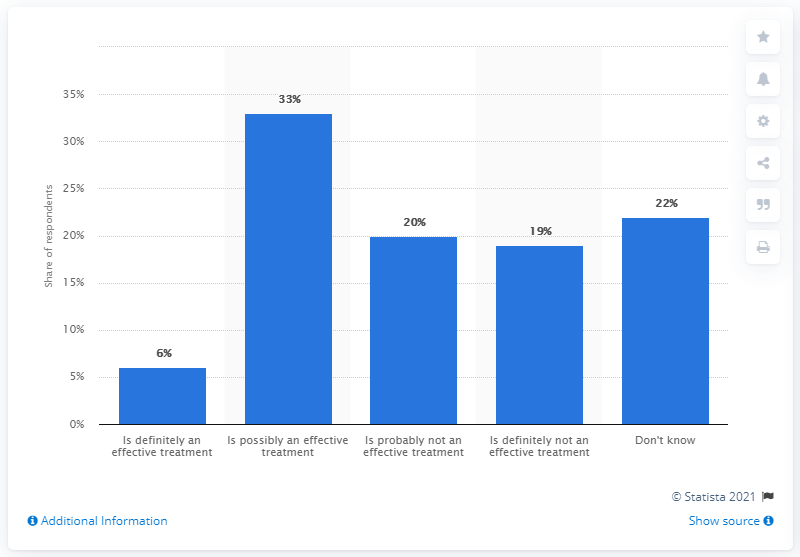Draw attention to some important aspects in this diagram. According to a survey, approximately 20% of British adults believe that homeopathy is not an effective treatment. 